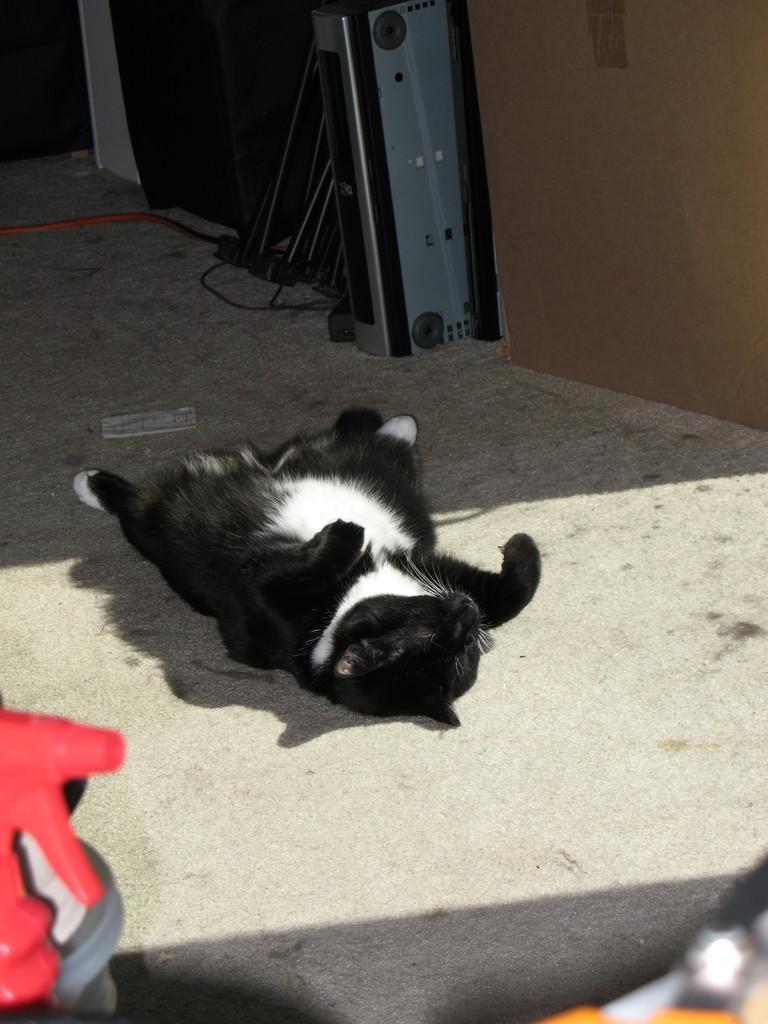Please provide a concise description of this image. In this image we can see a black and white colored cat on the floor, there is a paper, and also we can see some other objects. 